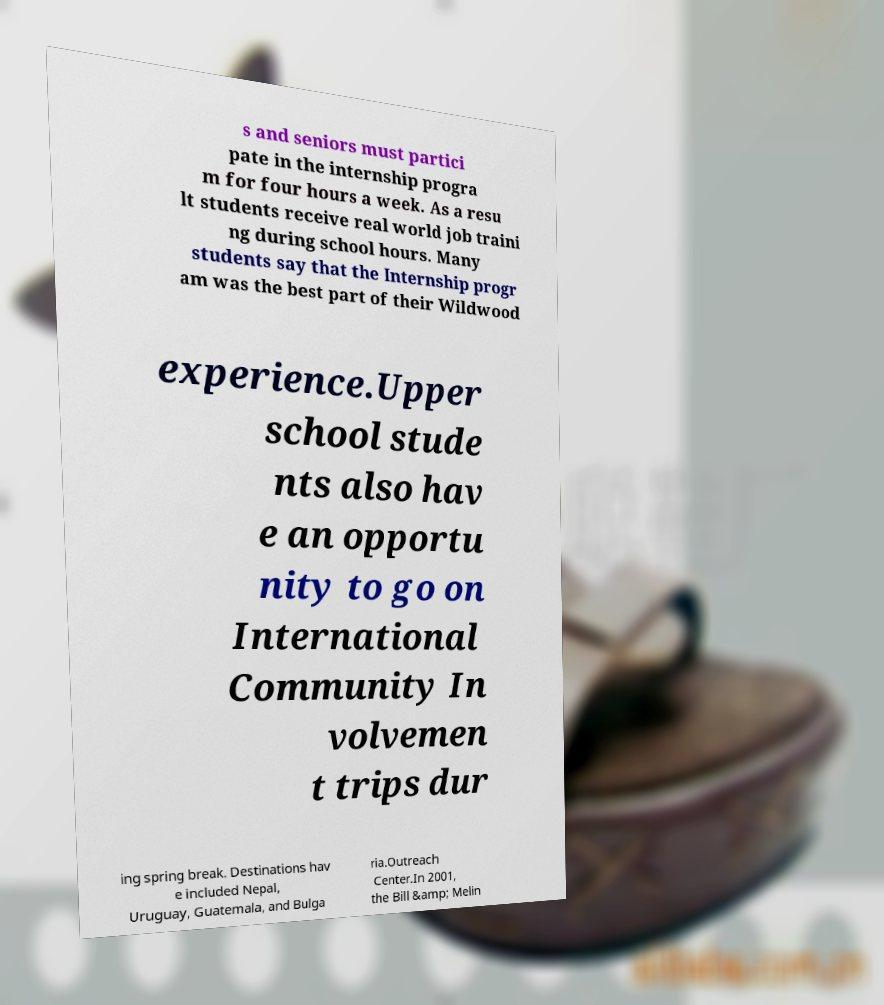There's text embedded in this image that I need extracted. Can you transcribe it verbatim? s and seniors must partici pate in the internship progra m for four hours a week. As a resu lt students receive real world job traini ng during school hours. Many students say that the Internship progr am was the best part of their Wildwood experience.Upper school stude nts also hav e an opportu nity to go on International Community In volvemen t trips dur ing spring break. Destinations hav e included Nepal, Uruguay, Guatemala, and Bulga ria.Outreach Center.In 2001, the Bill &amp; Melin 